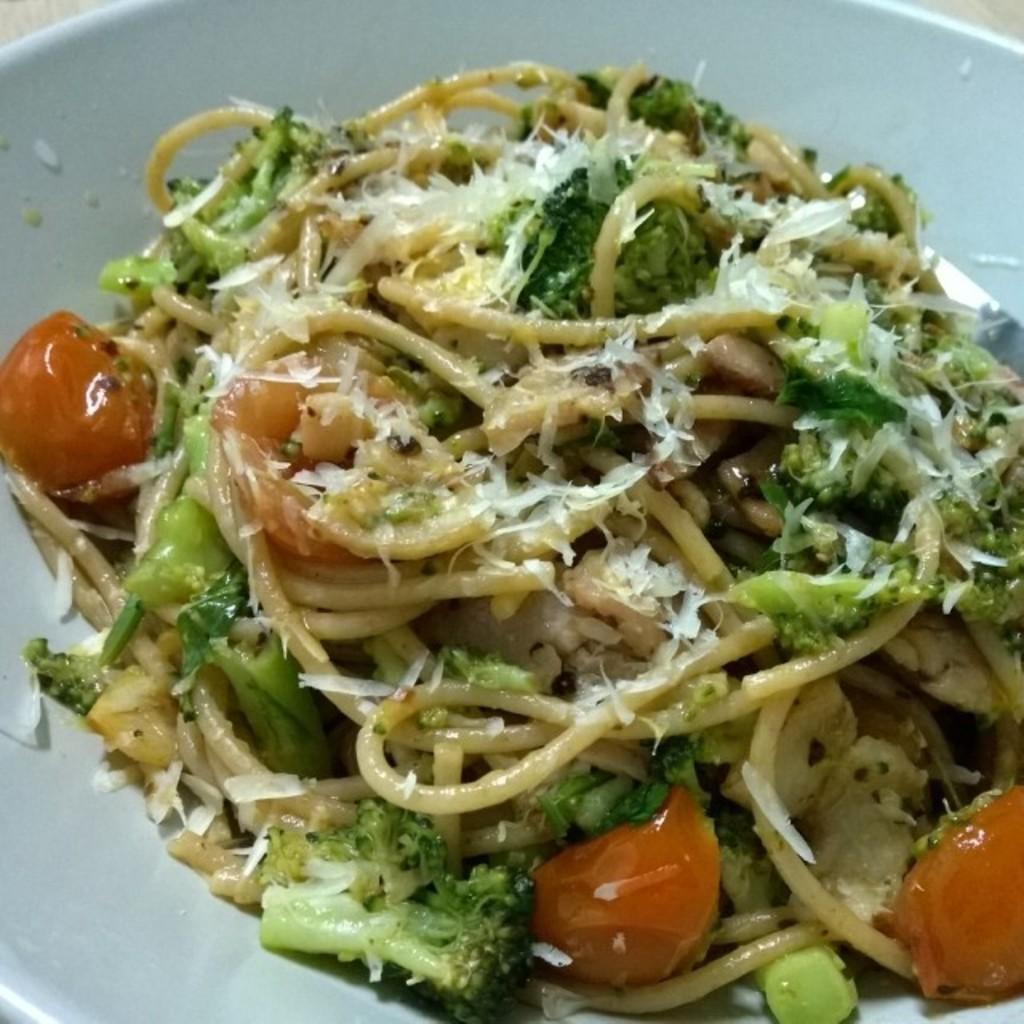What is the main subject of the image? There is a food item in the image. What is the food item placed on? The food item is on a white object. How does the food item express its feelings in the image? Food items do not have feelings, so this question cannot be answered. 